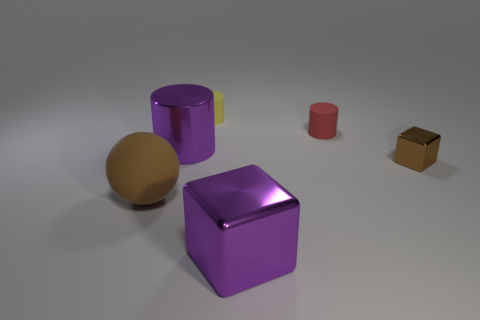There is a object that is the same color as the big metal block; what is its shape?
Your response must be concise. Cylinder. What is the size of the matte cylinder that is in front of the yellow cylinder?
Offer a very short reply. Small. Is the color of the block in front of the tiny brown cube the same as the large rubber ball?
Provide a short and direct response. No. What is the size of the brown thing on the left side of the cube in front of the big matte object?
Make the answer very short. Large. Is the number of large brown objects that are behind the brown cube greater than the number of red shiny balls?
Provide a short and direct response. No. Does the brown thing to the right of the purple metal block have the same size as the small yellow rubber object?
Provide a succinct answer. Yes. There is a metallic thing that is both on the left side of the brown metal block and behind the brown sphere; what color is it?
Keep it short and to the point. Purple. The red rubber object that is the same size as the brown block is what shape?
Give a very brief answer. Cylinder. Is there a big thing of the same color as the big metal cylinder?
Offer a terse response. Yes. Is the number of matte spheres that are to the right of the large cube the same as the number of small purple matte spheres?
Your answer should be compact. Yes. 